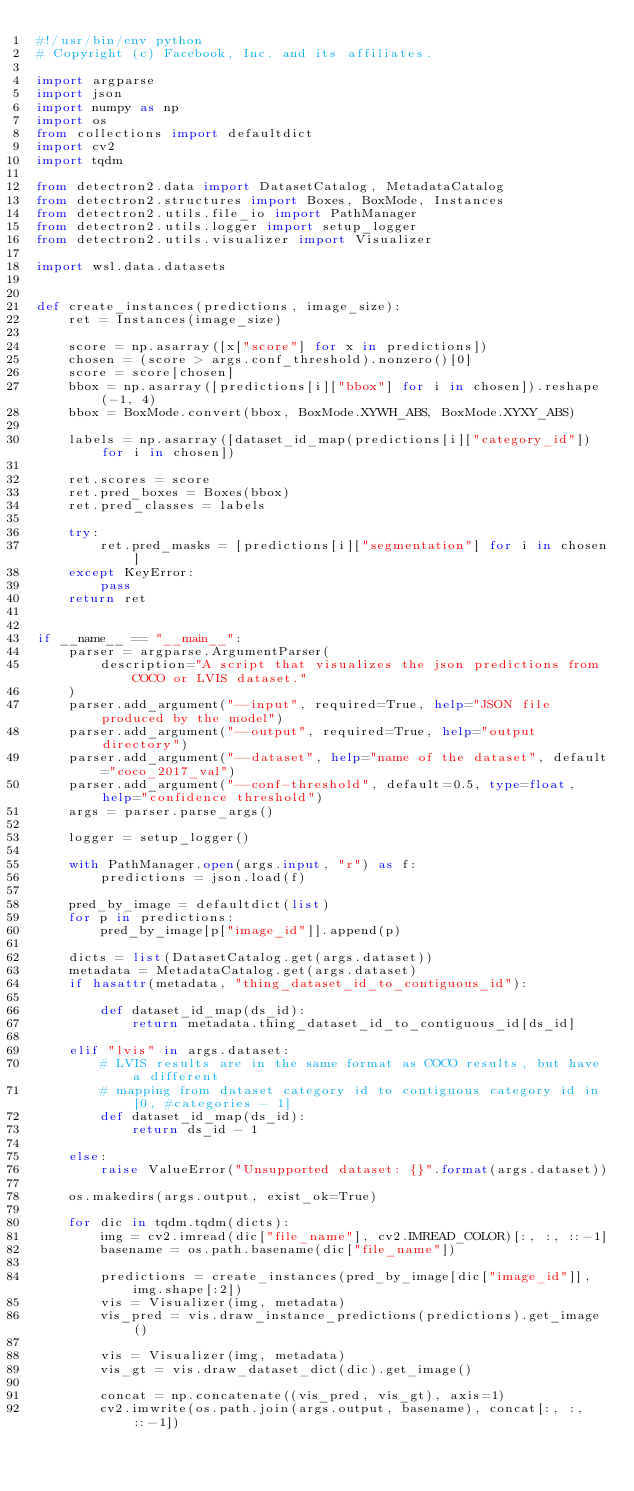Convert code to text. <code><loc_0><loc_0><loc_500><loc_500><_Python_>#!/usr/bin/env python
# Copyright (c) Facebook, Inc. and its affiliates.

import argparse
import json
import numpy as np
import os
from collections import defaultdict
import cv2
import tqdm

from detectron2.data import DatasetCatalog, MetadataCatalog
from detectron2.structures import Boxes, BoxMode, Instances
from detectron2.utils.file_io import PathManager
from detectron2.utils.logger import setup_logger
from detectron2.utils.visualizer import Visualizer

import wsl.data.datasets


def create_instances(predictions, image_size):
    ret = Instances(image_size)

    score = np.asarray([x["score"] for x in predictions])
    chosen = (score > args.conf_threshold).nonzero()[0]
    score = score[chosen]
    bbox = np.asarray([predictions[i]["bbox"] for i in chosen]).reshape(-1, 4)
    bbox = BoxMode.convert(bbox, BoxMode.XYWH_ABS, BoxMode.XYXY_ABS)

    labels = np.asarray([dataset_id_map(predictions[i]["category_id"]) for i in chosen])

    ret.scores = score
    ret.pred_boxes = Boxes(bbox)
    ret.pred_classes = labels

    try:
        ret.pred_masks = [predictions[i]["segmentation"] for i in chosen]
    except KeyError:
        pass
    return ret


if __name__ == "__main__":
    parser = argparse.ArgumentParser(
        description="A script that visualizes the json predictions from COCO or LVIS dataset."
    )
    parser.add_argument("--input", required=True, help="JSON file produced by the model")
    parser.add_argument("--output", required=True, help="output directory")
    parser.add_argument("--dataset", help="name of the dataset", default="coco_2017_val")
    parser.add_argument("--conf-threshold", default=0.5, type=float, help="confidence threshold")
    args = parser.parse_args()

    logger = setup_logger()

    with PathManager.open(args.input, "r") as f:
        predictions = json.load(f)

    pred_by_image = defaultdict(list)
    for p in predictions:
        pred_by_image[p["image_id"]].append(p)

    dicts = list(DatasetCatalog.get(args.dataset))
    metadata = MetadataCatalog.get(args.dataset)
    if hasattr(metadata, "thing_dataset_id_to_contiguous_id"):

        def dataset_id_map(ds_id):
            return metadata.thing_dataset_id_to_contiguous_id[ds_id]

    elif "lvis" in args.dataset:
        # LVIS results are in the same format as COCO results, but have a different
        # mapping from dataset category id to contiguous category id in [0, #categories - 1]
        def dataset_id_map(ds_id):
            return ds_id - 1

    else:
        raise ValueError("Unsupported dataset: {}".format(args.dataset))

    os.makedirs(args.output, exist_ok=True)

    for dic in tqdm.tqdm(dicts):
        img = cv2.imread(dic["file_name"], cv2.IMREAD_COLOR)[:, :, ::-1]
        basename = os.path.basename(dic["file_name"])

        predictions = create_instances(pred_by_image[dic["image_id"]], img.shape[:2])
        vis = Visualizer(img, metadata)
        vis_pred = vis.draw_instance_predictions(predictions).get_image()

        vis = Visualizer(img, metadata)
        vis_gt = vis.draw_dataset_dict(dic).get_image()

        concat = np.concatenate((vis_pred, vis_gt), axis=1)
        cv2.imwrite(os.path.join(args.output, basename), concat[:, :, ::-1])
</code> 